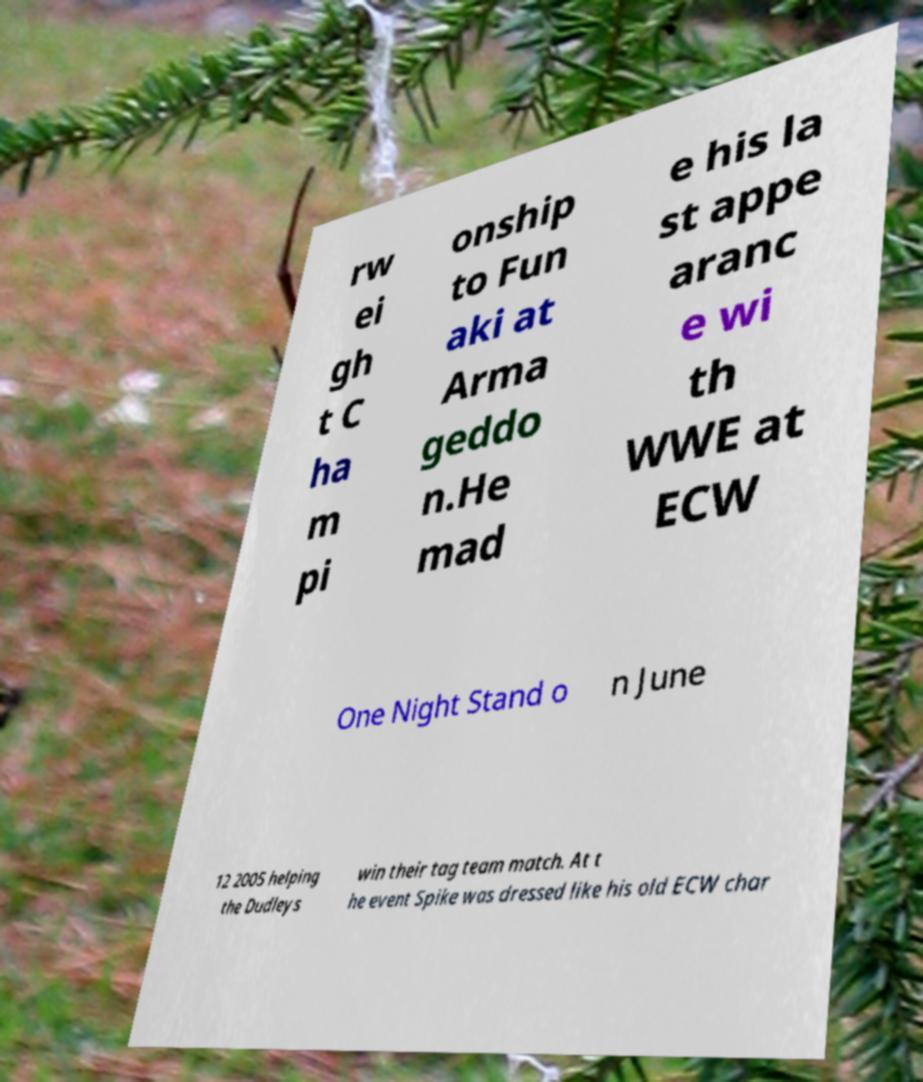Could you extract and type out the text from this image? rw ei gh t C ha m pi onship to Fun aki at Arma geddo n.He mad e his la st appe aranc e wi th WWE at ECW One Night Stand o n June 12 2005 helping the Dudleys win their tag team match. At t he event Spike was dressed like his old ECW char 